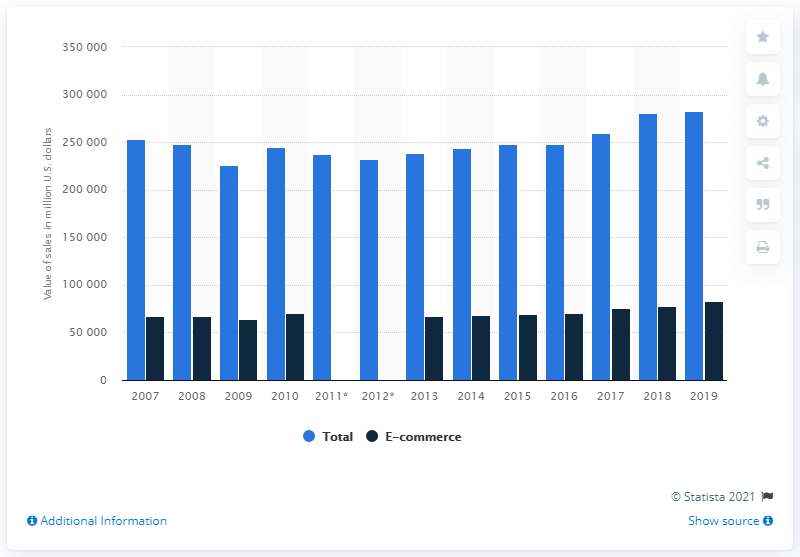Give some essential details in this illustration. In 2019, the value of B2B e-commerce sales of computer and computer peripheral equipment and software was approximately $83,324. 